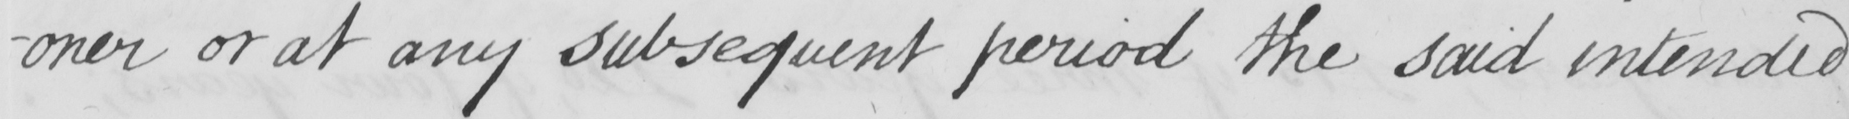Please provide the text content of this handwritten line. -oner or at any subsequent period the said intended 